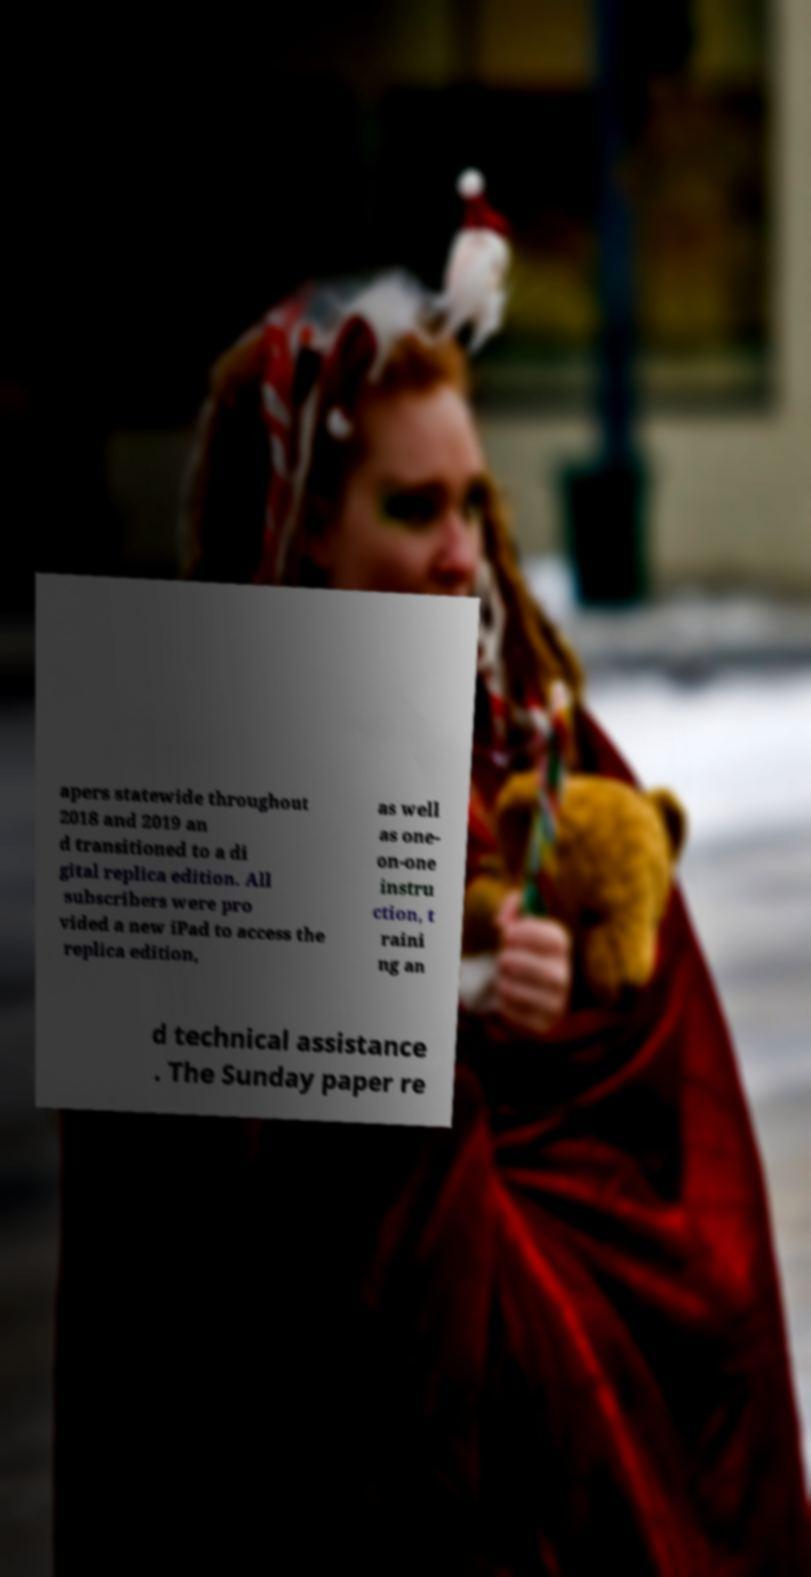I need the written content from this picture converted into text. Can you do that? apers statewide throughout 2018 and 2019 an d transitioned to a di gital replica edition. All subscribers were pro vided a new iPad to access the replica edition, as well as one- on-one instru ction, t raini ng an d technical assistance . The Sunday paper re 